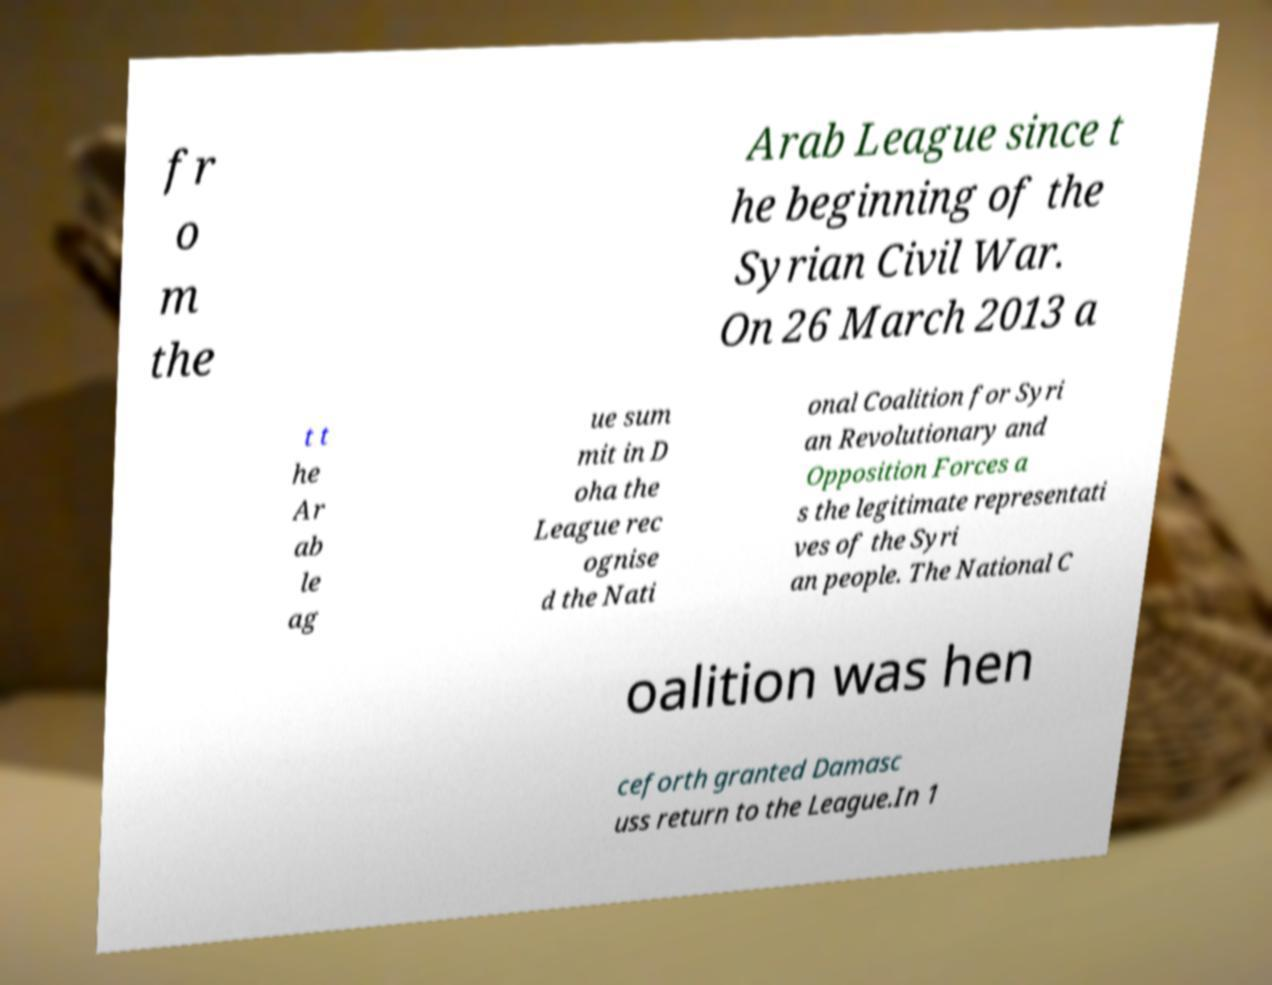I need the written content from this picture converted into text. Can you do that? fr o m the Arab League since t he beginning of the Syrian Civil War. On 26 March 2013 a t t he Ar ab le ag ue sum mit in D oha the League rec ognise d the Nati onal Coalition for Syri an Revolutionary and Opposition Forces a s the legitimate representati ves of the Syri an people. The National C oalition was hen ceforth granted Damasc uss return to the League.In 1 